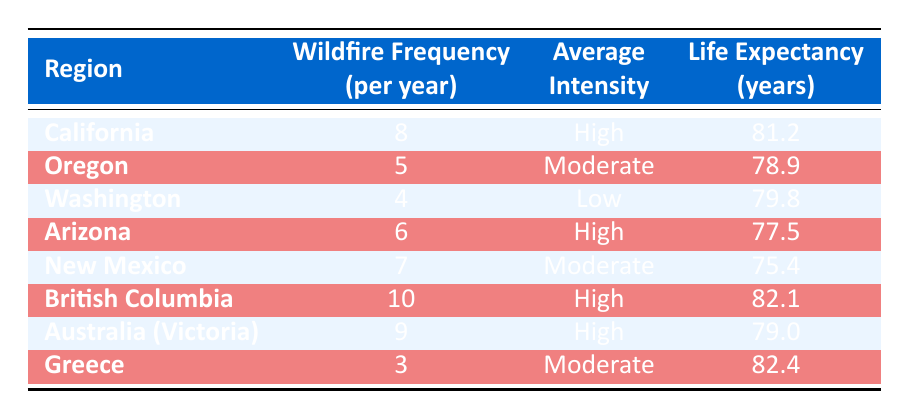What is the life expectancy in California? The table states the life expectancy for California is mentioned directly in the corresponding row under the Life Expectancy (years) column.
Answer: 81.2 Which region has the highest wildfire frequency per year? By examining the Wildfire Frequency (per year) column, British Columbia shows the highest value of 10.
Answer: British Columbia Is there a region with a wildfires frequency of 3? Looking at the Wildfire Frequency (per year) column, only Greece has a frequency value of 3.
Answer: Yes What is the average life expectancy of regions with high average intensity? First, identify the regions with High intensity, which are California, Arizona, British Columbia, and Australia (Victoria). Their life expectancies are 81.2, 77.5, 82.1, and 79.0 respectively. The average is calculated as (81.2 + 77.5 + 82.1 + 79.0) / 4 = 79.95.
Answer: 79.95 How many regions have a wildfire frequency greater than 6? Counting the wildfire frequency column, California (8), Arizona (6), and British Columbia (10) exceed a frequency of 6. This totals 4 regions (California, Arizona, New Mexico, and British Columbia).
Answer: 4 What is the difference between the life expectancies of Greece and New Mexico? The life expectancy for Greece is 82.4, and for New Mexico, it is 75.4. The difference is calculated as 82.4 - 75.4 = 7.
Answer: 7 Does higher wildfire frequency correlate with lower life expectancy? Comparing the data, we see (California with 8 frequency and 81.2 life expectancy, New Mexico with 7 frequency and 75.4 life expectancy). Therefore, while California has a higher frequency, it also has a higher life expectancy, suggesting no direct correlation.
Answer: No Which region has a higher life expectancy: Washington or Oregon? By looking at the Life Expectancy (years) column, Washington has a life expectancy of 79.8 years, while Oregon has 78.9 years. Comparing these values shows Washington has a higher life expectancy.
Answer: Washington What is the average wildfire frequency across all regions in the table? The frequencies per year are 8, 5, 4, 6, 7, 10, 9, and 3. Adding them gives 52. There are 8 regions, so the average is 52 / 8 = 6.5.
Answer: 6.5 